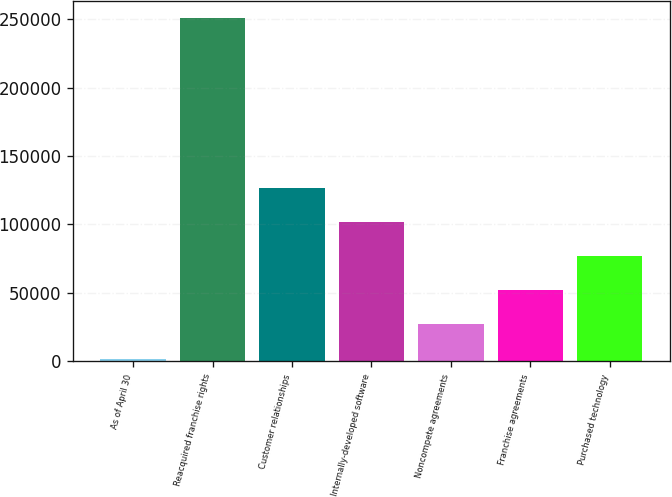<chart> <loc_0><loc_0><loc_500><loc_500><bar_chart><fcel>As of April 30<fcel>Reacquired franchise rights<fcel>Customer relationships<fcel>Internally-developed software<fcel>Noncompete agreements<fcel>Franchise agreements<fcel>Purchased technology<nl><fcel>2016<fcel>251070<fcel>126543<fcel>101638<fcel>26921.4<fcel>51826.8<fcel>76732.2<nl></chart> 